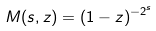Convert formula to latex. <formula><loc_0><loc_0><loc_500><loc_500>M ( s , z ) = ( 1 - z ) ^ { - 2 ^ { s } }</formula> 